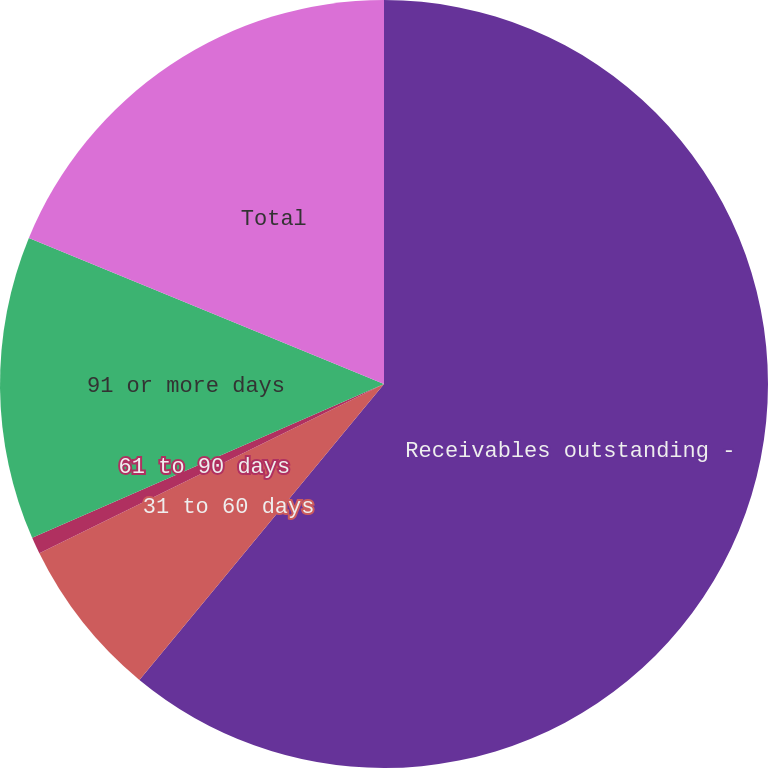Convert chart to OTSL. <chart><loc_0><loc_0><loc_500><loc_500><pie_chart><fcel>Receivables outstanding -<fcel>31 to 60 days<fcel>61 to 90 days<fcel>91 or more days<fcel>Total<nl><fcel>60.99%<fcel>6.74%<fcel>0.71%<fcel>12.77%<fcel>18.79%<nl></chart> 